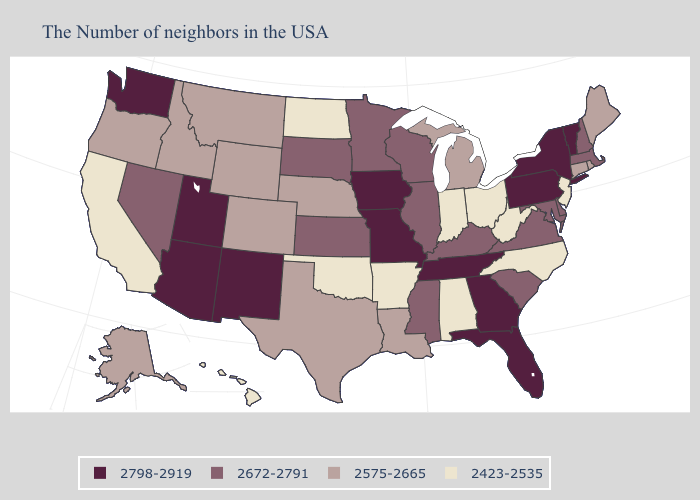What is the highest value in the MidWest ?
Keep it brief. 2798-2919. Does the first symbol in the legend represent the smallest category?
Be succinct. No. Does Missouri have the lowest value in the USA?
Concise answer only. No. Name the states that have a value in the range 2423-2535?
Quick response, please. New Jersey, North Carolina, West Virginia, Ohio, Indiana, Alabama, Arkansas, Oklahoma, North Dakota, California, Hawaii. What is the highest value in the USA?
Be succinct. 2798-2919. Which states have the highest value in the USA?
Answer briefly. Vermont, New York, Pennsylvania, Florida, Georgia, Tennessee, Missouri, Iowa, New Mexico, Utah, Arizona, Washington. Which states have the highest value in the USA?
Quick response, please. Vermont, New York, Pennsylvania, Florida, Georgia, Tennessee, Missouri, Iowa, New Mexico, Utah, Arizona, Washington. Which states have the lowest value in the USA?
Short answer required. New Jersey, North Carolina, West Virginia, Ohio, Indiana, Alabama, Arkansas, Oklahoma, North Dakota, California, Hawaii. Among the states that border Colorado , does Utah have the highest value?
Answer briefly. Yes. What is the value of West Virginia?
Be succinct. 2423-2535. What is the value of Connecticut?
Answer briefly. 2575-2665. Name the states that have a value in the range 2423-2535?
Keep it brief. New Jersey, North Carolina, West Virginia, Ohio, Indiana, Alabama, Arkansas, Oklahoma, North Dakota, California, Hawaii. Does Missouri have a lower value than Maine?
Keep it brief. No. Name the states that have a value in the range 2798-2919?
Quick response, please. Vermont, New York, Pennsylvania, Florida, Georgia, Tennessee, Missouri, Iowa, New Mexico, Utah, Arizona, Washington. 